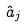Convert formula to latex. <formula><loc_0><loc_0><loc_500><loc_500>\hat { a } _ { j }</formula> 